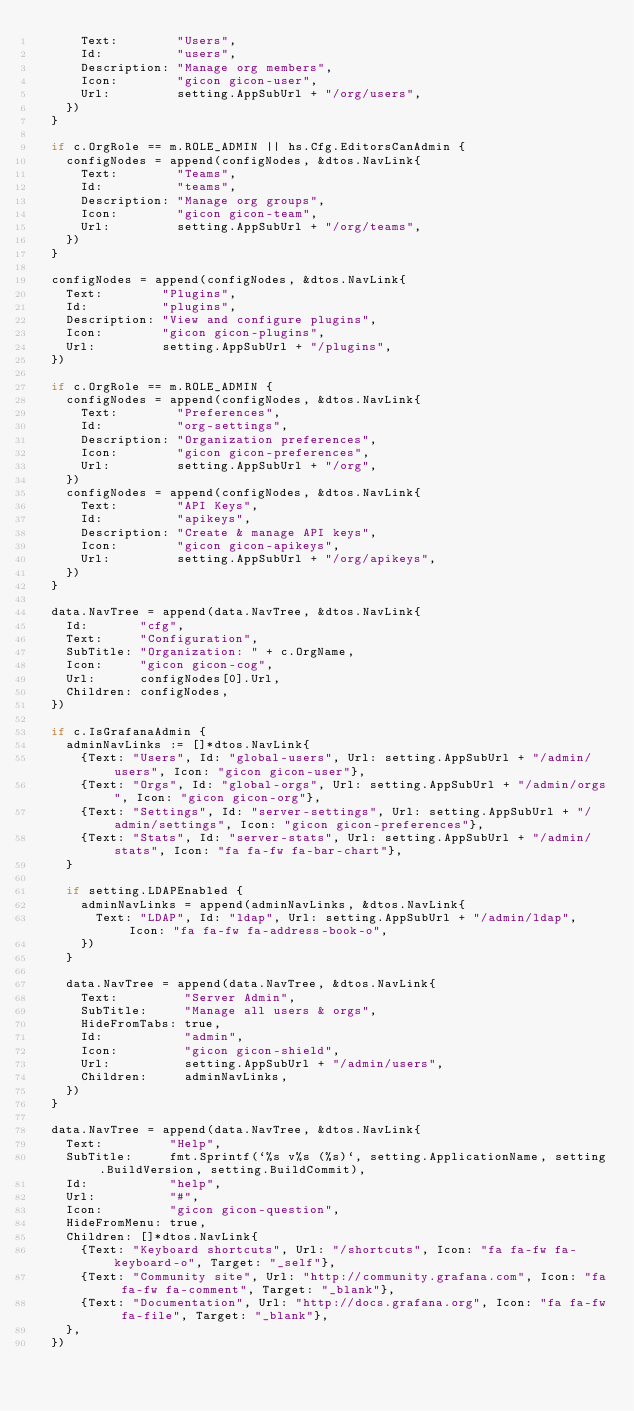Convert code to text. <code><loc_0><loc_0><loc_500><loc_500><_Go_>			Text:        "Users",
			Id:          "users",
			Description: "Manage org members",
			Icon:        "gicon gicon-user",
			Url:         setting.AppSubUrl + "/org/users",
		})
	}

	if c.OrgRole == m.ROLE_ADMIN || hs.Cfg.EditorsCanAdmin {
		configNodes = append(configNodes, &dtos.NavLink{
			Text:        "Teams",
			Id:          "teams",
			Description: "Manage org groups",
			Icon:        "gicon gicon-team",
			Url:         setting.AppSubUrl + "/org/teams",
		})
	}

	configNodes = append(configNodes, &dtos.NavLink{
		Text:        "Plugins",
		Id:          "plugins",
		Description: "View and configure plugins",
		Icon:        "gicon gicon-plugins",
		Url:         setting.AppSubUrl + "/plugins",
	})

	if c.OrgRole == m.ROLE_ADMIN {
		configNodes = append(configNodes, &dtos.NavLink{
			Text:        "Preferences",
			Id:          "org-settings",
			Description: "Organization preferences",
			Icon:        "gicon gicon-preferences",
			Url:         setting.AppSubUrl + "/org",
		})
		configNodes = append(configNodes, &dtos.NavLink{
			Text:        "API Keys",
			Id:          "apikeys",
			Description: "Create & manage API keys",
			Icon:        "gicon gicon-apikeys",
			Url:         setting.AppSubUrl + "/org/apikeys",
		})
	}

	data.NavTree = append(data.NavTree, &dtos.NavLink{
		Id:       "cfg",
		Text:     "Configuration",
		SubTitle: "Organization: " + c.OrgName,
		Icon:     "gicon gicon-cog",
		Url:      configNodes[0].Url,
		Children: configNodes,
	})

	if c.IsGrafanaAdmin {
		adminNavLinks := []*dtos.NavLink{
			{Text: "Users", Id: "global-users", Url: setting.AppSubUrl + "/admin/users", Icon: "gicon gicon-user"},
			{Text: "Orgs", Id: "global-orgs", Url: setting.AppSubUrl + "/admin/orgs", Icon: "gicon gicon-org"},
			{Text: "Settings", Id: "server-settings", Url: setting.AppSubUrl + "/admin/settings", Icon: "gicon gicon-preferences"},
			{Text: "Stats", Id: "server-stats", Url: setting.AppSubUrl + "/admin/stats", Icon: "fa fa-fw fa-bar-chart"},
		}

		if setting.LDAPEnabled {
			adminNavLinks = append(adminNavLinks, &dtos.NavLink{
				Text: "LDAP", Id: "ldap", Url: setting.AppSubUrl + "/admin/ldap", Icon: "fa fa-fw fa-address-book-o",
			})
		}

		data.NavTree = append(data.NavTree, &dtos.NavLink{
			Text:         "Server Admin",
			SubTitle:     "Manage all users & orgs",
			HideFromTabs: true,
			Id:           "admin",
			Icon:         "gicon gicon-shield",
			Url:          setting.AppSubUrl + "/admin/users",
			Children:     adminNavLinks,
		})
	}

	data.NavTree = append(data.NavTree, &dtos.NavLink{
		Text:         "Help",
		SubTitle:     fmt.Sprintf(`%s v%s (%s)`, setting.ApplicationName, setting.BuildVersion, setting.BuildCommit),
		Id:           "help",
		Url:          "#",
		Icon:         "gicon gicon-question",
		HideFromMenu: true,
		Children: []*dtos.NavLink{
			{Text: "Keyboard shortcuts", Url: "/shortcuts", Icon: "fa fa-fw fa-keyboard-o", Target: "_self"},
			{Text: "Community site", Url: "http://community.grafana.com", Icon: "fa fa-fw fa-comment", Target: "_blank"},
			{Text: "Documentation", Url: "http://docs.grafana.org", Icon: "fa fa-fw fa-file", Target: "_blank"},
		},
	})
</code> 